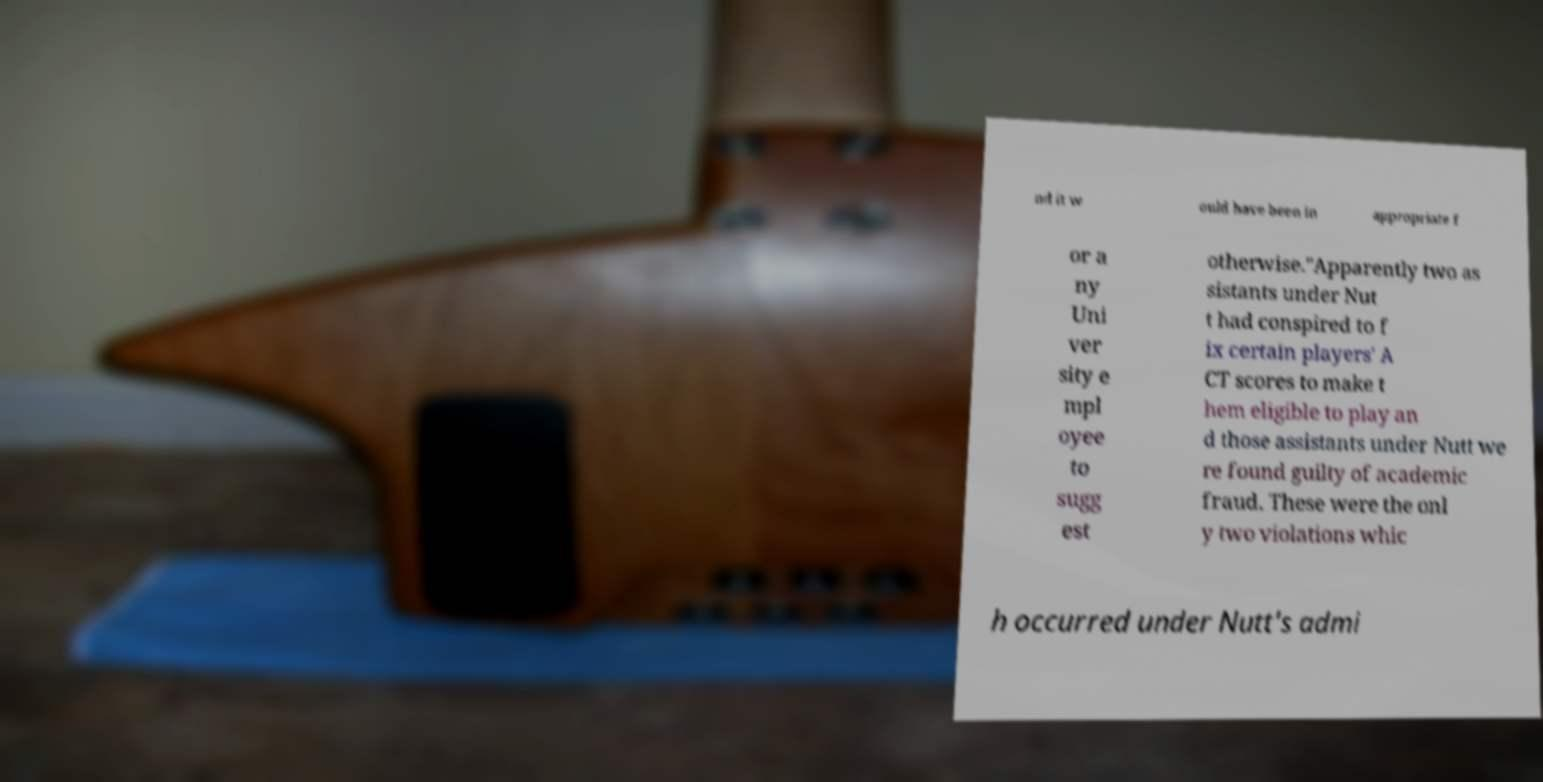Could you extract and type out the text from this image? nd it w ould have been in appropriate f or a ny Uni ver sity e mpl oyee to sugg est otherwise."Apparently two as sistants under Nut t had conspired to f ix certain players' A CT scores to make t hem eligible to play an d those assistants under Nutt we re found guilty of academic fraud. These were the onl y two violations whic h occurred under Nutt's admi 